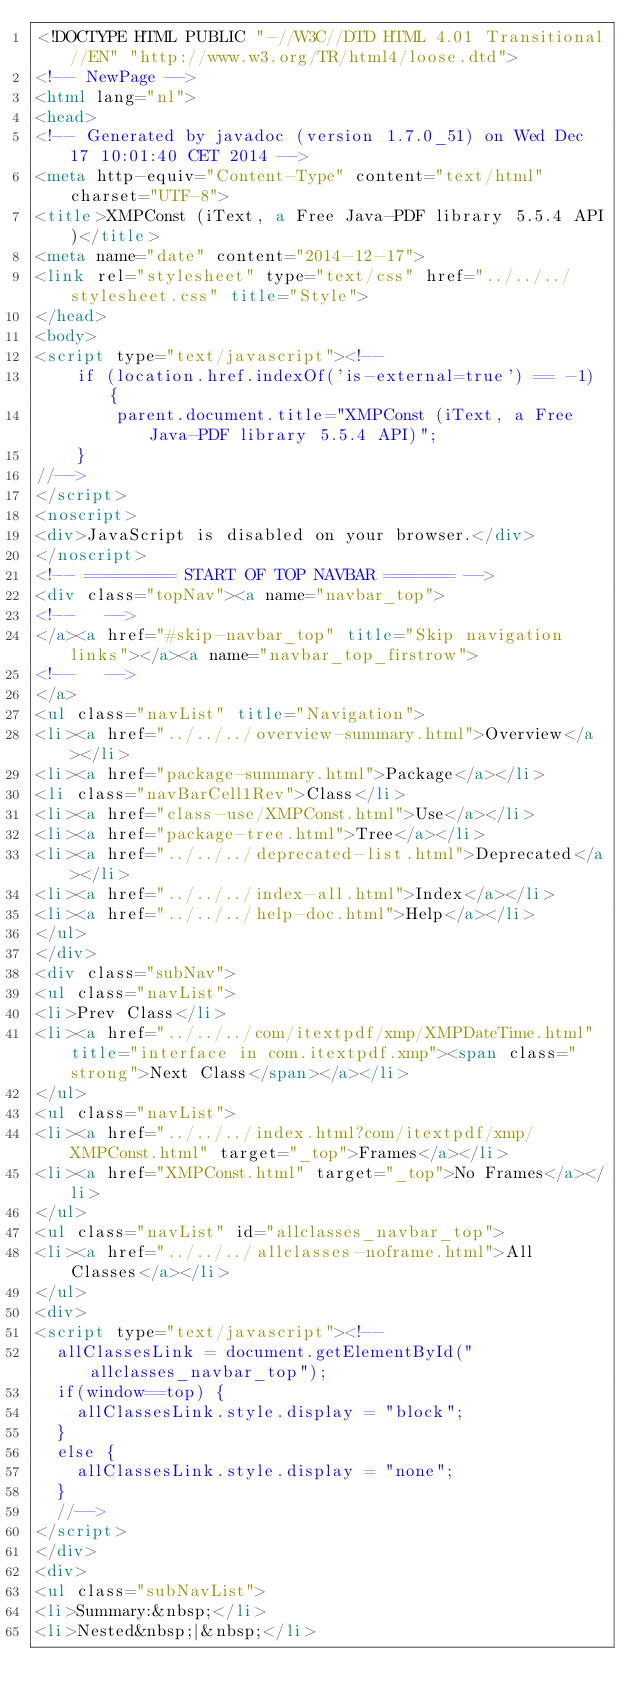Convert code to text. <code><loc_0><loc_0><loc_500><loc_500><_HTML_><!DOCTYPE HTML PUBLIC "-//W3C//DTD HTML 4.01 Transitional//EN" "http://www.w3.org/TR/html4/loose.dtd">
<!-- NewPage -->
<html lang="nl">
<head>
<!-- Generated by javadoc (version 1.7.0_51) on Wed Dec 17 10:01:40 CET 2014 -->
<meta http-equiv="Content-Type" content="text/html" charset="UTF-8">
<title>XMPConst (iText, a Free Java-PDF library 5.5.4 API)</title>
<meta name="date" content="2014-12-17">
<link rel="stylesheet" type="text/css" href="../../../stylesheet.css" title="Style">
</head>
<body>
<script type="text/javascript"><!--
    if (location.href.indexOf('is-external=true') == -1) {
        parent.document.title="XMPConst (iText, a Free Java-PDF library 5.5.4 API)";
    }
//-->
</script>
<noscript>
<div>JavaScript is disabled on your browser.</div>
</noscript>
<!-- ========= START OF TOP NAVBAR ======= -->
<div class="topNav"><a name="navbar_top">
<!--   -->
</a><a href="#skip-navbar_top" title="Skip navigation links"></a><a name="navbar_top_firstrow">
<!--   -->
</a>
<ul class="navList" title="Navigation">
<li><a href="../../../overview-summary.html">Overview</a></li>
<li><a href="package-summary.html">Package</a></li>
<li class="navBarCell1Rev">Class</li>
<li><a href="class-use/XMPConst.html">Use</a></li>
<li><a href="package-tree.html">Tree</a></li>
<li><a href="../../../deprecated-list.html">Deprecated</a></li>
<li><a href="../../../index-all.html">Index</a></li>
<li><a href="../../../help-doc.html">Help</a></li>
</ul>
</div>
<div class="subNav">
<ul class="navList">
<li>Prev Class</li>
<li><a href="../../../com/itextpdf/xmp/XMPDateTime.html" title="interface in com.itextpdf.xmp"><span class="strong">Next Class</span></a></li>
</ul>
<ul class="navList">
<li><a href="../../../index.html?com/itextpdf/xmp/XMPConst.html" target="_top">Frames</a></li>
<li><a href="XMPConst.html" target="_top">No Frames</a></li>
</ul>
<ul class="navList" id="allclasses_navbar_top">
<li><a href="../../../allclasses-noframe.html">All Classes</a></li>
</ul>
<div>
<script type="text/javascript"><!--
  allClassesLink = document.getElementById("allclasses_navbar_top");
  if(window==top) {
    allClassesLink.style.display = "block";
  }
  else {
    allClassesLink.style.display = "none";
  }
  //-->
</script>
</div>
<div>
<ul class="subNavList">
<li>Summary:&nbsp;</li>
<li>Nested&nbsp;|&nbsp;</li></code> 